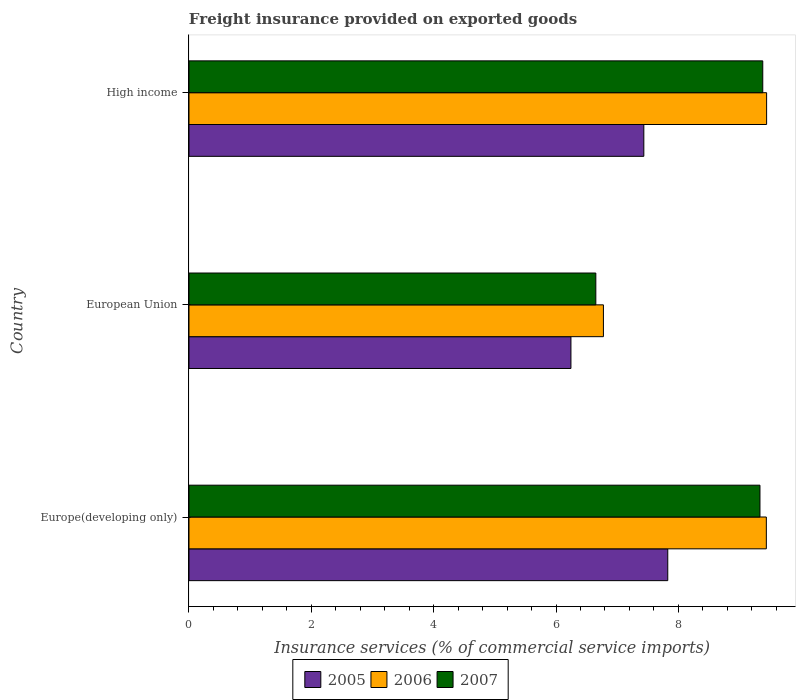Are the number of bars on each tick of the Y-axis equal?
Your answer should be very brief. Yes. How many bars are there on the 1st tick from the bottom?
Provide a succinct answer. 3. What is the label of the 1st group of bars from the top?
Provide a short and direct response. High income. What is the freight insurance provided on exported goods in 2007 in European Union?
Ensure brevity in your answer.  6.65. Across all countries, what is the maximum freight insurance provided on exported goods in 2007?
Your answer should be compact. 9.38. Across all countries, what is the minimum freight insurance provided on exported goods in 2007?
Keep it short and to the point. 6.65. In which country was the freight insurance provided on exported goods in 2006 maximum?
Your response must be concise. High income. What is the total freight insurance provided on exported goods in 2006 in the graph?
Offer a terse response. 25.65. What is the difference between the freight insurance provided on exported goods in 2006 in Europe(developing only) and that in High income?
Offer a very short reply. -0. What is the difference between the freight insurance provided on exported goods in 2005 in Europe(developing only) and the freight insurance provided on exported goods in 2006 in High income?
Provide a succinct answer. -1.62. What is the average freight insurance provided on exported goods in 2005 per country?
Your answer should be compact. 7.17. What is the difference between the freight insurance provided on exported goods in 2006 and freight insurance provided on exported goods in 2007 in Europe(developing only)?
Your response must be concise. 0.1. What is the ratio of the freight insurance provided on exported goods in 2006 in European Union to that in High income?
Ensure brevity in your answer.  0.72. Is the difference between the freight insurance provided on exported goods in 2006 in European Union and High income greater than the difference between the freight insurance provided on exported goods in 2007 in European Union and High income?
Your answer should be compact. Yes. What is the difference between the highest and the second highest freight insurance provided on exported goods in 2005?
Provide a short and direct response. 0.39. What is the difference between the highest and the lowest freight insurance provided on exported goods in 2006?
Your answer should be compact. 2.67. Is the sum of the freight insurance provided on exported goods in 2007 in European Union and High income greater than the maximum freight insurance provided on exported goods in 2006 across all countries?
Provide a short and direct response. Yes. What does the 1st bar from the bottom in High income represents?
Ensure brevity in your answer.  2005. What is the difference between two consecutive major ticks on the X-axis?
Give a very brief answer. 2. Are the values on the major ticks of X-axis written in scientific E-notation?
Keep it short and to the point. No. Does the graph contain any zero values?
Keep it short and to the point. No. How many legend labels are there?
Offer a terse response. 3. What is the title of the graph?
Ensure brevity in your answer.  Freight insurance provided on exported goods. Does "2004" appear as one of the legend labels in the graph?
Ensure brevity in your answer.  No. What is the label or title of the X-axis?
Keep it short and to the point. Insurance services (% of commercial service imports). What is the label or title of the Y-axis?
Make the answer very short. Country. What is the Insurance services (% of commercial service imports) in 2005 in Europe(developing only)?
Your answer should be very brief. 7.83. What is the Insurance services (% of commercial service imports) of 2006 in Europe(developing only)?
Provide a short and direct response. 9.44. What is the Insurance services (% of commercial service imports) of 2007 in Europe(developing only)?
Your answer should be compact. 9.33. What is the Insurance services (% of commercial service imports) in 2005 in European Union?
Provide a succinct answer. 6.24. What is the Insurance services (% of commercial service imports) in 2006 in European Union?
Offer a terse response. 6.77. What is the Insurance services (% of commercial service imports) in 2007 in European Union?
Ensure brevity in your answer.  6.65. What is the Insurance services (% of commercial service imports) in 2005 in High income?
Provide a short and direct response. 7.43. What is the Insurance services (% of commercial service imports) of 2006 in High income?
Ensure brevity in your answer.  9.44. What is the Insurance services (% of commercial service imports) of 2007 in High income?
Provide a short and direct response. 9.38. Across all countries, what is the maximum Insurance services (% of commercial service imports) in 2005?
Make the answer very short. 7.83. Across all countries, what is the maximum Insurance services (% of commercial service imports) of 2006?
Provide a succinct answer. 9.44. Across all countries, what is the maximum Insurance services (% of commercial service imports) of 2007?
Offer a terse response. 9.38. Across all countries, what is the minimum Insurance services (% of commercial service imports) of 2005?
Your response must be concise. 6.24. Across all countries, what is the minimum Insurance services (% of commercial service imports) in 2006?
Provide a short and direct response. 6.77. Across all countries, what is the minimum Insurance services (% of commercial service imports) of 2007?
Offer a terse response. 6.65. What is the total Insurance services (% of commercial service imports) of 2005 in the graph?
Make the answer very short. 21.5. What is the total Insurance services (% of commercial service imports) in 2006 in the graph?
Give a very brief answer. 25.65. What is the total Insurance services (% of commercial service imports) of 2007 in the graph?
Your answer should be compact. 25.36. What is the difference between the Insurance services (% of commercial service imports) of 2005 in Europe(developing only) and that in European Union?
Provide a succinct answer. 1.58. What is the difference between the Insurance services (% of commercial service imports) in 2006 in Europe(developing only) and that in European Union?
Offer a very short reply. 2.66. What is the difference between the Insurance services (% of commercial service imports) of 2007 in Europe(developing only) and that in European Union?
Your response must be concise. 2.68. What is the difference between the Insurance services (% of commercial service imports) of 2005 in Europe(developing only) and that in High income?
Provide a short and direct response. 0.39. What is the difference between the Insurance services (% of commercial service imports) in 2006 in Europe(developing only) and that in High income?
Keep it short and to the point. -0. What is the difference between the Insurance services (% of commercial service imports) in 2007 in Europe(developing only) and that in High income?
Keep it short and to the point. -0.05. What is the difference between the Insurance services (% of commercial service imports) of 2005 in European Union and that in High income?
Offer a terse response. -1.19. What is the difference between the Insurance services (% of commercial service imports) of 2006 in European Union and that in High income?
Your answer should be compact. -2.67. What is the difference between the Insurance services (% of commercial service imports) in 2007 in European Union and that in High income?
Your answer should be compact. -2.73. What is the difference between the Insurance services (% of commercial service imports) of 2005 in Europe(developing only) and the Insurance services (% of commercial service imports) of 2006 in European Union?
Ensure brevity in your answer.  1.05. What is the difference between the Insurance services (% of commercial service imports) in 2005 in Europe(developing only) and the Insurance services (% of commercial service imports) in 2007 in European Union?
Your answer should be compact. 1.18. What is the difference between the Insurance services (% of commercial service imports) in 2006 in Europe(developing only) and the Insurance services (% of commercial service imports) in 2007 in European Union?
Provide a short and direct response. 2.79. What is the difference between the Insurance services (% of commercial service imports) in 2005 in Europe(developing only) and the Insurance services (% of commercial service imports) in 2006 in High income?
Give a very brief answer. -1.62. What is the difference between the Insurance services (% of commercial service imports) in 2005 in Europe(developing only) and the Insurance services (% of commercial service imports) in 2007 in High income?
Provide a short and direct response. -1.55. What is the difference between the Insurance services (% of commercial service imports) in 2006 in Europe(developing only) and the Insurance services (% of commercial service imports) in 2007 in High income?
Ensure brevity in your answer.  0.06. What is the difference between the Insurance services (% of commercial service imports) in 2005 in European Union and the Insurance services (% of commercial service imports) in 2006 in High income?
Provide a succinct answer. -3.2. What is the difference between the Insurance services (% of commercial service imports) of 2005 in European Union and the Insurance services (% of commercial service imports) of 2007 in High income?
Ensure brevity in your answer.  -3.14. What is the difference between the Insurance services (% of commercial service imports) of 2006 in European Union and the Insurance services (% of commercial service imports) of 2007 in High income?
Keep it short and to the point. -2.6. What is the average Insurance services (% of commercial service imports) in 2005 per country?
Make the answer very short. 7.17. What is the average Insurance services (% of commercial service imports) of 2006 per country?
Your answer should be very brief. 8.55. What is the average Insurance services (% of commercial service imports) of 2007 per country?
Offer a terse response. 8.45. What is the difference between the Insurance services (% of commercial service imports) of 2005 and Insurance services (% of commercial service imports) of 2006 in Europe(developing only)?
Keep it short and to the point. -1.61. What is the difference between the Insurance services (% of commercial service imports) in 2005 and Insurance services (% of commercial service imports) in 2007 in Europe(developing only)?
Your answer should be very brief. -1.51. What is the difference between the Insurance services (% of commercial service imports) of 2006 and Insurance services (% of commercial service imports) of 2007 in Europe(developing only)?
Make the answer very short. 0.1. What is the difference between the Insurance services (% of commercial service imports) in 2005 and Insurance services (% of commercial service imports) in 2006 in European Union?
Your answer should be compact. -0.53. What is the difference between the Insurance services (% of commercial service imports) in 2005 and Insurance services (% of commercial service imports) in 2007 in European Union?
Your response must be concise. -0.41. What is the difference between the Insurance services (% of commercial service imports) in 2006 and Insurance services (% of commercial service imports) in 2007 in European Union?
Keep it short and to the point. 0.12. What is the difference between the Insurance services (% of commercial service imports) of 2005 and Insurance services (% of commercial service imports) of 2006 in High income?
Provide a short and direct response. -2.01. What is the difference between the Insurance services (% of commercial service imports) of 2005 and Insurance services (% of commercial service imports) of 2007 in High income?
Offer a terse response. -1.94. What is the difference between the Insurance services (% of commercial service imports) in 2006 and Insurance services (% of commercial service imports) in 2007 in High income?
Your response must be concise. 0.06. What is the ratio of the Insurance services (% of commercial service imports) in 2005 in Europe(developing only) to that in European Union?
Give a very brief answer. 1.25. What is the ratio of the Insurance services (% of commercial service imports) of 2006 in Europe(developing only) to that in European Union?
Your response must be concise. 1.39. What is the ratio of the Insurance services (% of commercial service imports) in 2007 in Europe(developing only) to that in European Union?
Offer a terse response. 1.4. What is the ratio of the Insurance services (% of commercial service imports) in 2005 in Europe(developing only) to that in High income?
Give a very brief answer. 1.05. What is the ratio of the Insurance services (% of commercial service imports) in 2005 in European Union to that in High income?
Provide a succinct answer. 0.84. What is the ratio of the Insurance services (% of commercial service imports) in 2006 in European Union to that in High income?
Give a very brief answer. 0.72. What is the ratio of the Insurance services (% of commercial service imports) of 2007 in European Union to that in High income?
Keep it short and to the point. 0.71. What is the difference between the highest and the second highest Insurance services (% of commercial service imports) of 2005?
Provide a short and direct response. 0.39. What is the difference between the highest and the second highest Insurance services (% of commercial service imports) of 2006?
Your answer should be very brief. 0. What is the difference between the highest and the second highest Insurance services (% of commercial service imports) of 2007?
Offer a terse response. 0.05. What is the difference between the highest and the lowest Insurance services (% of commercial service imports) in 2005?
Offer a very short reply. 1.58. What is the difference between the highest and the lowest Insurance services (% of commercial service imports) of 2006?
Keep it short and to the point. 2.67. What is the difference between the highest and the lowest Insurance services (% of commercial service imports) of 2007?
Make the answer very short. 2.73. 